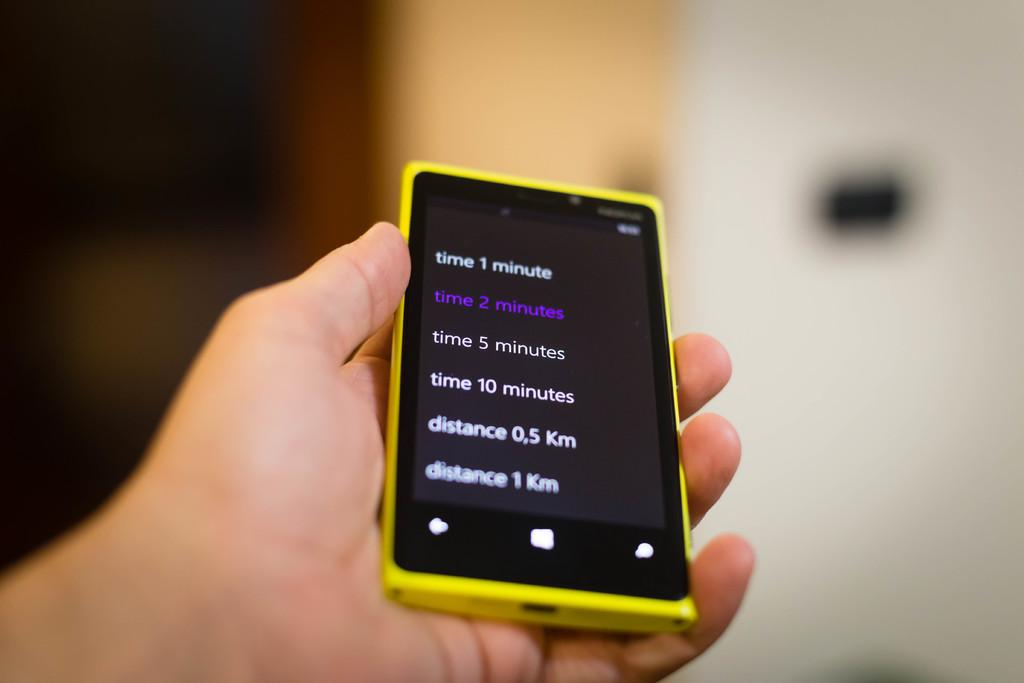Provide a one-sentence caption for the provided image. A smarphone with various times and distances on the screen. 